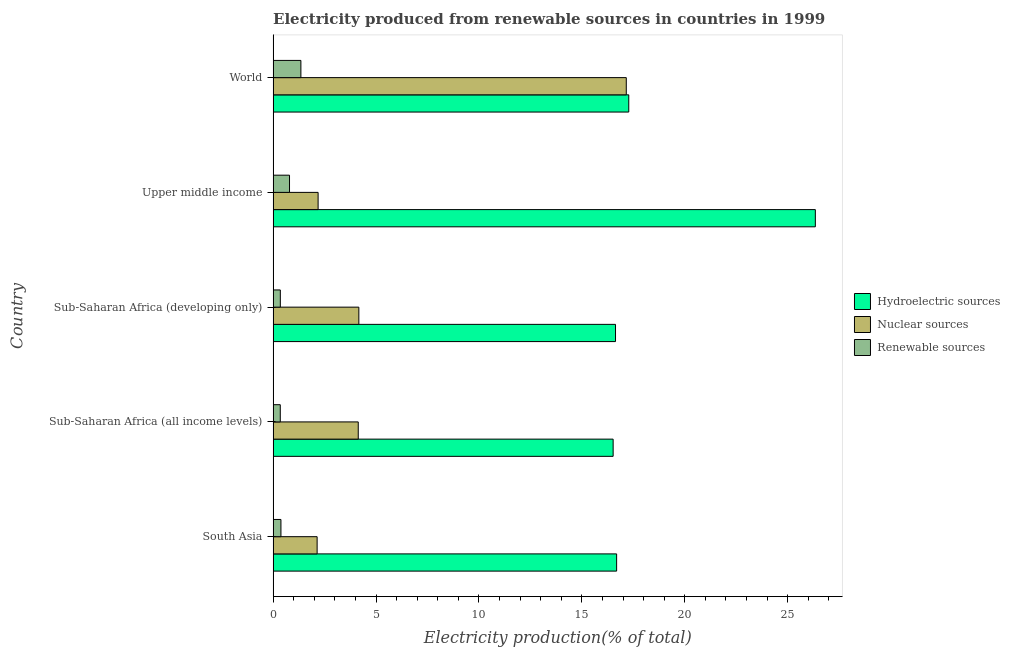How many different coloured bars are there?
Ensure brevity in your answer.  3. How many groups of bars are there?
Your response must be concise. 5. Are the number of bars per tick equal to the number of legend labels?
Provide a short and direct response. Yes. Are the number of bars on each tick of the Y-axis equal?
Provide a short and direct response. Yes. What is the label of the 3rd group of bars from the top?
Keep it short and to the point. Sub-Saharan Africa (developing only). What is the percentage of electricity produced by hydroelectric sources in Upper middle income?
Your answer should be compact. 26.34. Across all countries, what is the maximum percentage of electricity produced by nuclear sources?
Provide a succinct answer. 17.16. Across all countries, what is the minimum percentage of electricity produced by nuclear sources?
Offer a very short reply. 2.14. In which country was the percentage of electricity produced by nuclear sources maximum?
Ensure brevity in your answer.  World. In which country was the percentage of electricity produced by hydroelectric sources minimum?
Your response must be concise. Sub-Saharan Africa (all income levels). What is the total percentage of electricity produced by nuclear sources in the graph?
Offer a very short reply. 29.78. What is the difference between the percentage of electricity produced by nuclear sources in Sub-Saharan Africa (all income levels) and that in Sub-Saharan Africa (developing only)?
Keep it short and to the point. -0.03. What is the difference between the percentage of electricity produced by nuclear sources in World and the percentage of electricity produced by renewable sources in Upper middle income?
Give a very brief answer. 16.36. What is the average percentage of electricity produced by nuclear sources per country?
Your response must be concise. 5.96. What is the difference between the percentage of electricity produced by renewable sources and percentage of electricity produced by hydroelectric sources in Sub-Saharan Africa (developing only)?
Ensure brevity in your answer.  -16.28. In how many countries, is the percentage of electricity produced by nuclear sources greater than 12 %?
Ensure brevity in your answer.  1. What is the ratio of the percentage of electricity produced by renewable sources in Sub-Saharan Africa (all income levels) to that in World?
Your response must be concise. 0.26. Is the difference between the percentage of electricity produced by hydroelectric sources in Sub-Saharan Africa (all income levels) and Sub-Saharan Africa (developing only) greater than the difference between the percentage of electricity produced by renewable sources in Sub-Saharan Africa (all income levels) and Sub-Saharan Africa (developing only)?
Provide a succinct answer. No. What is the difference between the highest and the second highest percentage of electricity produced by hydroelectric sources?
Provide a short and direct response. 9.06. What is the difference between the highest and the lowest percentage of electricity produced by nuclear sources?
Keep it short and to the point. 15.02. Is the sum of the percentage of electricity produced by hydroelectric sources in Sub-Saharan Africa (all income levels) and World greater than the maximum percentage of electricity produced by renewable sources across all countries?
Keep it short and to the point. Yes. What does the 1st bar from the top in Sub-Saharan Africa (all income levels) represents?
Your answer should be compact. Renewable sources. What does the 3rd bar from the bottom in Sub-Saharan Africa (developing only) represents?
Provide a short and direct response. Renewable sources. How many bars are there?
Provide a succinct answer. 15. How many countries are there in the graph?
Give a very brief answer. 5. Are the values on the major ticks of X-axis written in scientific E-notation?
Give a very brief answer. No. Does the graph contain any zero values?
Make the answer very short. No. Does the graph contain grids?
Offer a very short reply. No. What is the title of the graph?
Give a very brief answer. Electricity produced from renewable sources in countries in 1999. What is the Electricity production(% of total) in Hydroelectric sources in South Asia?
Your response must be concise. 16.69. What is the Electricity production(% of total) of Nuclear sources in South Asia?
Provide a succinct answer. 2.14. What is the Electricity production(% of total) in Renewable sources in South Asia?
Ensure brevity in your answer.  0.38. What is the Electricity production(% of total) in Hydroelectric sources in Sub-Saharan Africa (all income levels)?
Provide a succinct answer. 16.52. What is the Electricity production(% of total) in Nuclear sources in Sub-Saharan Africa (all income levels)?
Offer a very short reply. 4.14. What is the Electricity production(% of total) in Renewable sources in Sub-Saharan Africa (all income levels)?
Your answer should be very brief. 0.35. What is the Electricity production(% of total) of Hydroelectric sources in Sub-Saharan Africa (developing only)?
Ensure brevity in your answer.  16.63. What is the Electricity production(% of total) in Nuclear sources in Sub-Saharan Africa (developing only)?
Make the answer very short. 4.16. What is the Electricity production(% of total) of Renewable sources in Sub-Saharan Africa (developing only)?
Your answer should be very brief. 0.35. What is the Electricity production(% of total) of Hydroelectric sources in Upper middle income?
Your answer should be compact. 26.34. What is the Electricity production(% of total) of Nuclear sources in Upper middle income?
Your answer should be compact. 2.19. What is the Electricity production(% of total) in Renewable sources in Upper middle income?
Offer a terse response. 0.8. What is the Electricity production(% of total) of Hydroelectric sources in World?
Your answer should be very brief. 17.28. What is the Electricity production(% of total) of Nuclear sources in World?
Offer a terse response. 17.16. What is the Electricity production(% of total) in Renewable sources in World?
Provide a short and direct response. 1.35. Across all countries, what is the maximum Electricity production(% of total) of Hydroelectric sources?
Offer a very short reply. 26.34. Across all countries, what is the maximum Electricity production(% of total) in Nuclear sources?
Ensure brevity in your answer.  17.16. Across all countries, what is the maximum Electricity production(% of total) of Renewable sources?
Your response must be concise. 1.35. Across all countries, what is the minimum Electricity production(% of total) in Hydroelectric sources?
Keep it short and to the point. 16.52. Across all countries, what is the minimum Electricity production(% of total) in Nuclear sources?
Offer a terse response. 2.14. Across all countries, what is the minimum Electricity production(% of total) in Renewable sources?
Provide a succinct answer. 0.35. What is the total Electricity production(% of total) of Hydroelectric sources in the graph?
Your response must be concise. 93.46. What is the total Electricity production(% of total) of Nuclear sources in the graph?
Provide a short and direct response. 29.78. What is the total Electricity production(% of total) in Renewable sources in the graph?
Your answer should be compact. 3.22. What is the difference between the Electricity production(% of total) of Hydroelectric sources in South Asia and that in Sub-Saharan Africa (all income levels)?
Your response must be concise. 0.17. What is the difference between the Electricity production(% of total) of Nuclear sources in South Asia and that in Sub-Saharan Africa (all income levels)?
Provide a short and direct response. -2. What is the difference between the Electricity production(% of total) of Renewable sources in South Asia and that in Sub-Saharan Africa (all income levels)?
Give a very brief answer. 0.03. What is the difference between the Electricity production(% of total) of Hydroelectric sources in South Asia and that in Sub-Saharan Africa (developing only)?
Your answer should be compact. 0.05. What is the difference between the Electricity production(% of total) in Nuclear sources in South Asia and that in Sub-Saharan Africa (developing only)?
Your answer should be very brief. -2.03. What is the difference between the Electricity production(% of total) in Renewable sources in South Asia and that in Sub-Saharan Africa (developing only)?
Ensure brevity in your answer.  0.03. What is the difference between the Electricity production(% of total) of Hydroelectric sources in South Asia and that in Upper middle income?
Your answer should be compact. -9.65. What is the difference between the Electricity production(% of total) of Nuclear sources in South Asia and that in Upper middle income?
Make the answer very short. -0.05. What is the difference between the Electricity production(% of total) in Renewable sources in South Asia and that in Upper middle income?
Provide a succinct answer. -0.42. What is the difference between the Electricity production(% of total) in Hydroelectric sources in South Asia and that in World?
Provide a short and direct response. -0.59. What is the difference between the Electricity production(% of total) in Nuclear sources in South Asia and that in World?
Provide a succinct answer. -15.02. What is the difference between the Electricity production(% of total) of Renewable sources in South Asia and that in World?
Give a very brief answer. -0.97. What is the difference between the Electricity production(% of total) of Hydroelectric sources in Sub-Saharan Africa (all income levels) and that in Sub-Saharan Africa (developing only)?
Give a very brief answer. -0.12. What is the difference between the Electricity production(% of total) of Nuclear sources in Sub-Saharan Africa (all income levels) and that in Sub-Saharan Africa (developing only)?
Make the answer very short. -0.03. What is the difference between the Electricity production(% of total) in Renewable sources in Sub-Saharan Africa (all income levels) and that in Sub-Saharan Africa (developing only)?
Keep it short and to the point. -0. What is the difference between the Electricity production(% of total) of Hydroelectric sources in Sub-Saharan Africa (all income levels) and that in Upper middle income?
Offer a terse response. -9.82. What is the difference between the Electricity production(% of total) of Nuclear sources in Sub-Saharan Africa (all income levels) and that in Upper middle income?
Your answer should be very brief. 1.95. What is the difference between the Electricity production(% of total) of Renewable sources in Sub-Saharan Africa (all income levels) and that in Upper middle income?
Your response must be concise. -0.45. What is the difference between the Electricity production(% of total) of Hydroelectric sources in Sub-Saharan Africa (all income levels) and that in World?
Your response must be concise. -0.76. What is the difference between the Electricity production(% of total) in Nuclear sources in Sub-Saharan Africa (all income levels) and that in World?
Offer a terse response. -13.02. What is the difference between the Electricity production(% of total) in Renewable sources in Sub-Saharan Africa (all income levels) and that in World?
Offer a terse response. -1. What is the difference between the Electricity production(% of total) in Hydroelectric sources in Sub-Saharan Africa (developing only) and that in Upper middle income?
Your response must be concise. -9.71. What is the difference between the Electricity production(% of total) of Nuclear sources in Sub-Saharan Africa (developing only) and that in Upper middle income?
Provide a succinct answer. 1.98. What is the difference between the Electricity production(% of total) in Renewable sources in Sub-Saharan Africa (developing only) and that in Upper middle income?
Ensure brevity in your answer.  -0.45. What is the difference between the Electricity production(% of total) of Hydroelectric sources in Sub-Saharan Africa (developing only) and that in World?
Provide a short and direct response. -0.64. What is the difference between the Electricity production(% of total) in Nuclear sources in Sub-Saharan Africa (developing only) and that in World?
Give a very brief answer. -12.99. What is the difference between the Electricity production(% of total) in Renewable sources in Sub-Saharan Africa (developing only) and that in World?
Your response must be concise. -1. What is the difference between the Electricity production(% of total) in Hydroelectric sources in Upper middle income and that in World?
Provide a short and direct response. 9.06. What is the difference between the Electricity production(% of total) of Nuclear sources in Upper middle income and that in World?
Provide a succinct answer. -14.97. What is the difference between the Electricity production(% of total) of Renewable sources in Upper middle income and that in World?
Keep it short and to the point. -0.55. What is the difference between the Electricity production(% of total) in Hydroelectric sources in South Asia and the Electricity production(% of total) in Nuclear sources in Sub-Saharan Africa (all income levels)?
Your answer should be very brief. 12.55. What is the difference between the Electricity production(% of total) in Hydroelectric sources in South Asia and the Electricity production(% of total) in Renewable sources in Sub-Saharan Africa (all income levels)?
Provide a succinct answer. 16.34. What is the difference between the Electricity production(% of total) of Nuclear sources in South Asia and the Electricity production(% of total) of Renewable sources in Sub-Saharan Africa (all income levels)?
Give a very brief answer. 1.79. What is the difference between the Electricity production(% of total) of Hydroelectric sources in South Asia and the Electricity production(% of total) of Nuclear sources in Sub-Saharan Africa (developing only)?
Your response must be concise. 12.52. What is the difference between the Electricity production(% of total) in Hydroelectric sources in South Asia and the Electricity production(% of total) in Renewable sources in Sub-Saharan Africa (developing only)?
Offer a terse response. 16.34. What is the difference between the Electricity production(% of total) of Nuclear sources in South Asia and the Electricity production(% of total) of Renewable sources in Sub-Saharan Africa (developing only)?
Offer a very short reply. 1.79. What is the difference between the Electricity production(% of total) in Hydroelectric sources in South Asia and the Electricity production(% of total) in Nuclear sources in Upper middle income?
Provide a short and direct response. 14.5. What is the difference between the Electricity production(% of total) of Hydroelectric sources in South Asia and the Electricity production(% of total) of Renewable sources in Upper middle income?
Make the answer very short. 15.89. What is the difference between the Electricity production(% of total) in Nuclear sources in South Asia and the Electricity production(% of total) in Renewable sources in Upper middle income?
Your answer should be compact. 1.34. What is the difference between the Electricity production(% of total) of Hydroelectric sources in South Asia and the Electricity production(% of total) of Nuclear sources in World?
Make the answer very short. -0.47. What is the difference between the Electricity production(% of total) of Hydroelectric sources in South Asia and the Electricity production(% of total) of Renewable sources in World?
Offer a very short reply. 15.34. What is the difference between the Electricity production(% of total) of Nuclear sources in South Asia and the Electricity production(% of total) of Renewable sources in World?
Offer a terse response. 0.79. What is the difference between the Electricity production(% of total) in Hydroelectric sources in Sub-Saharan Africa (all income levels) and the Electricity production(% of total) in Nuclear sources in Sub-Saharan Africa (developing only)?
Offer a very short reply. 12.35. What is the difference between the Electricity production(% of total) in Hydroelectric sources in Sub-Saharan Africa (all income levels) and the Electricity production(% of total) in Renewable sources in Sub-Saharan Africa (developing only)?
Provide a succinct answer. 16.17. What is the difference between the Electricity production(% of total) in Nuclear sources in Sub-Saharan Africa (all income levels) and the Electricity production(% of total) in Renewable sources in Sub-Saharan Africa (developing only)?
Offer a very short reply. 3.79. What is the difference between the Electricity production(% of total) in Hydroelectric sources in Sub-Saharan Africa (all income levels) and the Electricity production(% of total) in Nuclear sources in Upper middle income?
Provide a succinct answer. 14.33. What is the difference between the Electricity production(% of total) of Hydroelectric sources in Sub-Saharan Africa (all income levels) and the Electricity production(% of total) of Renewable sources in Upper middle income?
Offer a very short reply. 15.72. What is the difference between the Electricity production(% of total) of Nuclear sources in Sub-Saharan Africa (all income levels) and the Electricity production(% of total) of Renewable sources in Upper middle income?
Your response must be concise. 3.34. What is the difference between the Electricity production(% of total) in Hydroelectric sources in Sub-Saharan Africa (all income levels) and the Electricity production(% of total) in Nuclear sources in World?
Offer a very short reply. -0.64. What is the difference between the Electricity production(% of total) of Hydroelectric sources in Sub-Saharan Africa (all income levels) and the Electricity production(% of total) of Renewable sources in World?
Your answer should be compact. 15.17. What is the difference between the Electricity production(% of total) of Nuclear sources in Sub-Saharan Africa (all income levels) and the Electricity production(% of total) of Renewable sources in World?
Give a very brief answer. 2.79. What is the difference between the Electricity production(% of total) of Hydroelectric sources in Sub-Saharan Africa (developing only) and the Electricity production(% of total) of Nuclear sources in Upper middle income?
Give a very brief answer. 14.45. What is the difference between the Electricity production(% of total) in Hydroelectric sources in Sub-Saharan Africa (developing only) and the Electricity production(% of total) in Renewable sources in Upper middle income?
Offer a terse response. 15.84. What is the difference between the Electricity production(% of total) in Nuclear sources in Sub-Saharan Africa (developing only) and the Electricity production(% of total) in Renewable sources in Upper middle income?
Ensure brevity in your answer.  3.37. What is the difference between the Electricity production(% of total) of Hydroelectric sources in Sub-Saharan Africa (developing only) and the Electricity production(% of total) of Nuclear sources in World?
Provide a succinct answer. -0.52. What is the difference between the Electricity production(% of total) of Hydroelectric sources in Sub-Saharan Africa (developing only) and the Electricity production(% of total) of Renewable sources in World?
Offer a very short reply. 15.29. What is the difference between the Electricity production(% of total) of Nuclear sources in Sub-Saharan Africa (developing only) and the Electricity production(% of total) of Renewable sources in World?
Ensure brevity in your answer.  2.82. What is the difference between the Electricity production(% of total) in Hydroelectric sources in Upper middle income and the Electricity production(% of total) in Nuclear sources in World?
Your response must be concise. 9.19. What is the difference between the Electricity production(% of total) of Hydroelectric sources in Upper middle income and the Electricity production(% of total) of Renewable sources in World?
Offer a terse response. 24.99. What is the difference between the Electricity production(% of total) in Nuclear sources in Upper middle income and the Electricity production(% of total) in Renewable sources in World?
Keep it short and to the point. 0.84. What is the average Electricity production(% of total) of Hydroelectric sources per country?
Provide a succinct answer. 18.69. What is the average Electricity production(% of total) in Nuclear sources per country?
Provide a short and direct response. 5.96. What is the average Electricity production(% of total) in Renewable sources per country?
Offer a very short reply. 0.64. What is the difference between the Electricity production(% of total) of Hydroelectric sources and Electricity production(% of total) of Nuclear sources in South Asia?
Your answer should be compact. 14.55. What is the difference between the Electricity production(% of total) in Hydroelectric sources and Electricity production(% of total) in Renewable sources in South Asia?
Your answer should be very brief. 16.31. What is the difference between the Electricity production(% of total) in Nuclear sources and Electricity production(% of total) in Renewable sources in South Asia?
Provide a short and direct response. 1.76. What is the difference between the Electricity production(% of total) in Hydroelectric sources and Electricity production(% of total) in Nuclear sources in Sub-Saharan Africa (all income levels)?
Make the answer very short. 12.38. What is the difference between the Electricity production(% of total) in Hydroelectric sources and Electricity production(% of total) in Renewable sources in Sub-Saharan Africa (all income levels)?
Give a very brief answer. 16.17. What is the difference between the Electricity production(% of total) in Nuclear sources and Electricity production(% of total) in Renewable sources in Sub-Saharan Africa (all income levels)?
Provide a short and direct response. 3.79. What is the difference between the Electricity production(% of total) in Hydroelectric sources and Electricity production(% of total) in Nuclear sources in Sub-Saharan Africa (developing only)?
Your answer should be very brief. 12.47. What is the difference between the Electricity production(% of total) in Hydroelectric sources and Electricity production(% of total) in Renewable sources in Sub-Saharan Africa (developing only)?
Your answer should be very brief. 16.28. What is the difference between the Electricity production(% of total) in Nuclear sources and Electricity production(% of total) in Renewable sources in Sub-Saharan Africa (developing only)?
Offer a very short reply. 3.81. What is the difference between the Electricity production(% of total) of Hydroelectric sources and Electricity production(% of total) of Nuclear sources in Upper middle income?
Your response must be concise. 24.16. What is the difference between the Electricity production(% of total) in Hydroelectric sources and Electricity production(% of total) in Renewable sources in Upper middle income?
Make the answer very short. 25.55. What is the difference between the Electricity production(% of total) of Nuclear sources and Electricity production(% of total) of Renewable sources in Upper middle income?
Offer a very short reply. 1.39. What is the difference between the Electricity production(% of total) in Hydroelectric sources and Electricity production(% of total) in Nuclear sources in World?
Give a very brief answer. 0.12. What is the difference between the Electricity production(% of total) of Hydroelectric sources and Electricity production(% of total) of Renewable sources in World?
Ensure brevity in your answer.  15.93. What is the difference between the Electricity production(% of total) of Nuclear sources and Electricity production(% of total) of Renewable sources in World?
Offer a terse response. 15.81. What is the ratio of the Electricity production(% of total) of Hydroelectric sources in South Asia to that in Sub-Saharan Africa (all income levels)?
Give a very brief answer. 1.01. What is the ratio of the Electricity production(% of total) of Nuclear sources in South Asia to that in Sub-Saharan Africa (all income levels)?
Ensure brevity in your answer.  0.52. What is the ratio of the Electricity production(% of total) of Renewable sources in South Asia to that in Sub-Saharan Africa (all income levels)?
Make the answer very short. 1.09. What is the ratio of the Electricity production(% of total) in Hydroelectric sources in South Asia to that in Sub-Saharan Africa (developing only)?
Make the answer very short. 1. What is the ratio of the Electricity production(% of total) of Nuclear sources in South Asia to that in Sub-Saharan Africa (developing only)?
Your answer should be very brief. 0.51. What is the ratio of the Electricity production(% of total) of Renewable sources in South Asia to that in Sub-Saharan Africa (developing only)?
Give a very brief answer. 1.08. What is the ratio of the Electricity production(% of total) in Hydroelectric sources in South Asia to that in Upper middle income?
Your answer should be very brief. 0.63. What is the ratio of the Electricity production(% of total) in Nuclear sources in South Asia to that in Upper middle income?
Provide a short and direct response. 0.98. What is the ratio of the Electricity production(% of total) in Renewable sources in South Asia to that in Upper middle income?
Give a very brief answer. 0.48. What is the ratio of the Electricity production(% of total) in Hydroelectric sources in South Asia to that in World?
Provide a succinct answer. 0.97. What is the ratio of the Electricity production(% of total) in Nuclear sources in South Asia to that in World?
Offer a very short reply. 0.12. What is the ratio of the Electricity production(% of total) in Renewable sources in South Asia to that in World?
Your answer should be compact. 0.28. What is the ratio of the Electricity production(% of total) in Nuclear sources in Sub-Saharan Africa (all income levels) to that in Sub-Saharan Africa (developing only)?
Provide a short and direct response. 0.99. What is the ratio of the Electricity production(% of total) in Renewable sources in Sub-Saharan Africa (all income levels) to that in Sub-Saharan Africa (developing only)?
Your response must be concise. 0.99. What is the ratio of the Electricity production(% of total) of Hydroelectric sources in Sub-Saharan Africa (all income levels) to that in Upper middle income?
Provide a short and direct response. 0.63. What is the ratio of the Electricity production(% of total) in Nuclear sources in Sub-Saharan Africa (all income levels) to that in Upper middle income?
Provide a succinct answer. 1.89. What is the ratio of the Electricity production(% of total) of Renewable sources in Sub-Saharan Africa (all income levels) to that in Upper middle income?
Keep it short and to the point. 0.44. What is the ratio of the Electricity production(% of total) of Hydroelectric sources in Sub-Saharan Africa (all income levels) to that in World?
Provide a short and direct response. 0.96. What is the ratio of the Electricity production(% of total) in Nuclear sources in Sub-Saharan Africa (all income levels) to that in World?
Ensure brevity in your answer.  0.24. What is the ratio of the Electricity production(% of total) of Renewable sources in Sub-Saharan Africa (all income levels) to that in World?
Your answer should be very brief. 0.26. What is the ratio of the Electricity production(% of total) of Hydroelectric sources in Sub-Saharan Africa (developing only) to that in Upper middle income?
Provide a succinct answer. 0.63. What is the ratio of the Electricity production(% of total) of Nuclear sources in Sub-Saharan Africa (developing only) to that in Upper middle income?
Offer a terse response. 1.91. What is the ratio of the Electricity production(% of total) in Renewable sources in Sub-Saharan Africa (developing only) to that in Upper middle income?
Give a very brief answer. 0.44. What is the ratio of the Electricity production(% of total) in Hydroelectric sources in Sub-Saharan Africa (developing only) to that in World?
Provide a short and direct response. 0.96. What is the ratio of the Electricity production(% of total) of Nuclear sources in Sub-Saharan Africa (developing only) to that in World?
Provide a short and direct response. 0.24. What is the ratio of the Electricity production(% of total) in Renewable sources in Sub-Saharan Africa (developing only) to that in World?
Your answer should be very brief. 0.26. What is the ratio of the Electricity production(% of total) in Hydroelectric sources in Upper middle income to that in World?
Provide a short and direct response. 1.52. What is the ratio of the Electricity production(% of total) of Nuclear sources in Upper middle income to that in World?
Keep it short and to the point. 0.13. What is the ratio of the Electricity production(% of total) in Renewable sources in Upper middle income to that in World?
Your answer should be compact. 0.59. What is the difference between the highest and the second highest Electricity production(% of total) of Hydroelectric sources?
Make the answer very short. 9.06. What is the difference between the highest and the second highest Electricity production(% of total) of Nuclear sources?
Provide a short and direct response. 12.99. What is the difference between the highest and the second highest Electricity production(% of total) in Renewable sources?
Offer a terse response. 0.55. What is the difference between the highest and the lowest Electricity production(% of total) of Hydroelectric sources?
Give a very brief answer. 9.82. What is the difference between the highest and the lowest Electricity production(% of total) in Nuclear sources?
Keep it short and to the point. 15.02. 